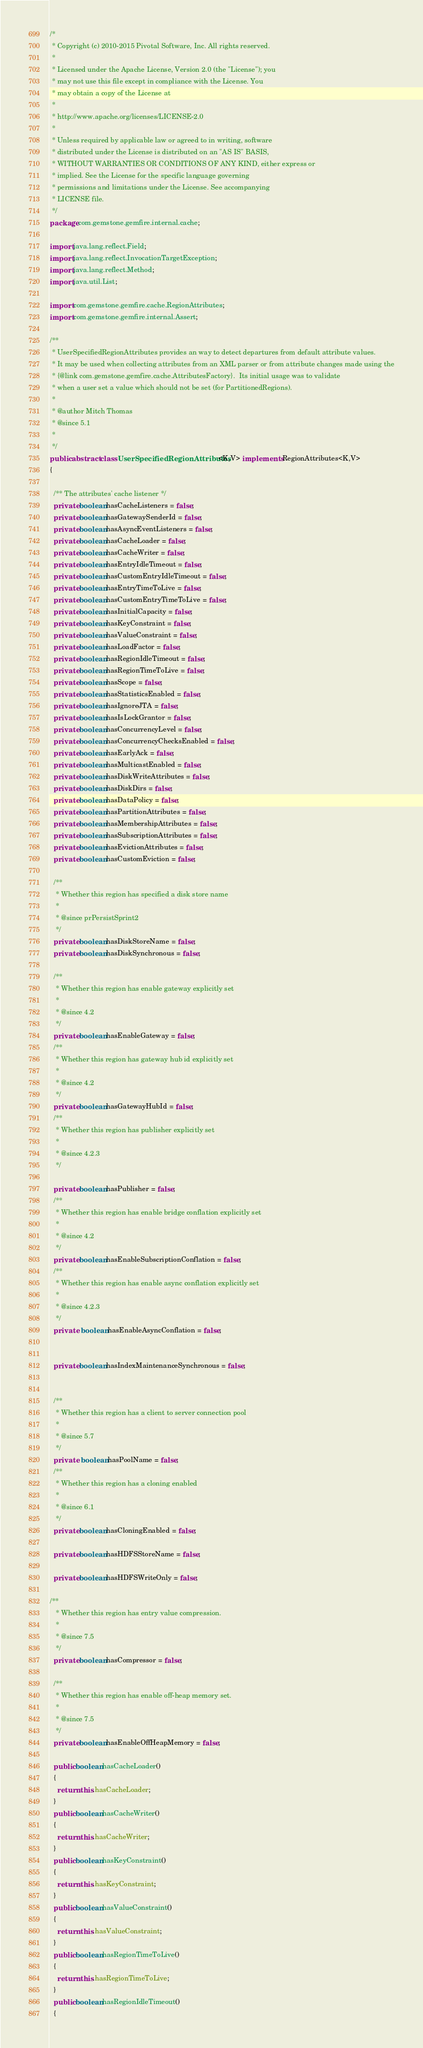Convert code to text. <code><loc_0><loc_0><loc_500><loc_500><_Java_>/*
 * Copyright (c) 2010-2015 Pivotal Software, Inc. All rights reserved.
 *
 * Licensed under the Apache License, Version 2.0 (the "License"); you
 * may not use this file except in compliance with the License. You
 * may obtain a copy of the License at
 *
 * http://www.apache.org/licenses/LICENSE-2.0
 *
 * Unless required by applicable law or agreed to in writing, software
 * distributed under the License is distributed on an "AS IS" BASIS,
 * WITHOUT WARRANTIES OR CONDITIONS OF ANY KIND, either express or
 * implied. See the License for the specific language governing
 * permissions and limitations under the License. See accompanying
 * LICENSE file.
 */
package com.gemstone.gemfire.internal.cache;

import java.lang.reflect.Field;
import java.lang.reflect.InvocationTargetException;
import java.lang.reflect.Method;
import java.util.List;

import com.gemstone.gemfire.cache.RegionAttributes;
import com.gemstone.gemfire.internal.Assert;

/**
 * UserSpecifiedRegionAttributes provides an way to detect departures from default attribute values.
 * It may be used when collecting attributes from an XML parser or from attribute changes made using the
 * {@link com.gemstone.gemfire.cache.AttributesFactory}.  Its initial usage was to validate
 * when a user set a value which should not be set (for PartitionedRegions).
 * 
 * @author Mitch Thomas
 * @since 5.1
 *
 */
public abstract class UserSpecifiedRegionAttributes<K,V> implements RegionAttributes<K,V>
{

  /** The attributes' cache listener */
  private boolean hasCacheListeners = false;
  private boolean hasGatewaySenderId = false;
  private boolean hasAsyncEventListeners = false;
  private boolean hasCacheLoader = false;
  private boolean hasCacheWriter = false;
  private boolean hasEntryIdleTimeout = false;
  private boolean hasCustomEntryIdleTimeout = false;
  private boolean hasEntryTimeToLive = false;
  private boolean hasCustomEntryTimeToLive = false;
  private boolean hasInitialCapacity = false;
  private boolean hasKeyConstraint = false;
  private boolean hasValueConstraint = false;
  private boolean hasLoadFactor = false;
  private boolean hasRegionIdleTimeout = false;
  private boolean hasRegionTimeToLive = false;
  private boolean hasScope = false;
  private boolean hasStatisticsEnabled = false;
  private boolean hasIgnoreJTA = false;
  private boolean hasIsLockGrantor = false;
  private boolean hasConcurrencyLevel = false;
  private boolean hasConcurrencyChecksEnabled = false;
  private boolean hasEarlyAck = false;
  private boolean hasMulticastEnabled = false;
  private boolean hasDiskWriteAttributes = false;
  private boolean hasDiskDirs = false;
  private boolean hasDataPolicy = false;
  private boolean hasPartitionAttributes = false;
  private boolean hasMembershipAttributes = false;
  private boolean hasSubscriptionAttributes = false;
  private boolean hasEvictionAttributes = false;
  private boolean hasCustomEviction = false;

  /**
   * Whether this region has specified a disk store name
   *
   * @since prPersistSprint2
   */
  private boolean hasDiskStoreName = false;
  private boolean hasDiskSynchronous = false;
  
  /**
   * Whether this region has enable gateway explicitly set
   *
   * @since 4.2
   */
  private boolean hasEnableGateway = false;
  /**
   * Whether this region has gateway hub id explicitly set
   *
   * @since 4.2
   */
  private boolean hasGatewayHubId = false;
  /**
   * Whether this region has publisher explicitly set
   *
   * @since 4.2.3
   */
  
  private boolean hasPublisher = false;
  /**
   * Whether this region has enable bridge conflation explicitly set
   *
   * @since 4.2
   */
  private boolean hasEnableSubscriptionConflation = false;
  /**
   * Whether this region has enable async conflation explicitly set
   *
   * @since 4.2.3
   */
  private  boolean hasEnableAsyncConflation = false;
  
  
  private boolean hasIndexMaintenanceSynchronous = false;
  
  
  /**
   * Whether this region has a client to server connection pool
   *
   * @since 5.7
   */
  private  boolean hasPoolName = false;
  /**
   * Whether this region has a cloning enabled
   *
   * @since 6.1
   */
  private boolean hasCloningEnabled = false;
  
  private boolean hasHDFSStoreName = false;
  
  private boolean hasHDFSWriteOnly = false;
  
/**
   * Whether this region has entry value compression.
   * 
   * @since 7.5
   */
  private boolean hasCompressor = false;
  
  /**
   * Whether this region has enable off-heap memory set.
   * 
   * @since 7.5
   */
  private boolean hasEnableOffHeapMemory = false;
  
  public boolean hasCacheLoader()
  {
    return this.hasCacheLoader;
  }
  public boolean hasCacheWriter()
  {
    return this.hasCacheWriter;
  }
  public boolean hasKeyConstraint()
  {
    return this.hasKeyConstraint;
  }
  public boolean hasValueConstraint()
  {
    return this.hasValueConstraint;
  }
  public boolean hasRegionTimeToLive()
  {
    return this.hasRegionTimeToLive;
  }
  public boolean hasRegionIdleTimeout()
  {</code> 